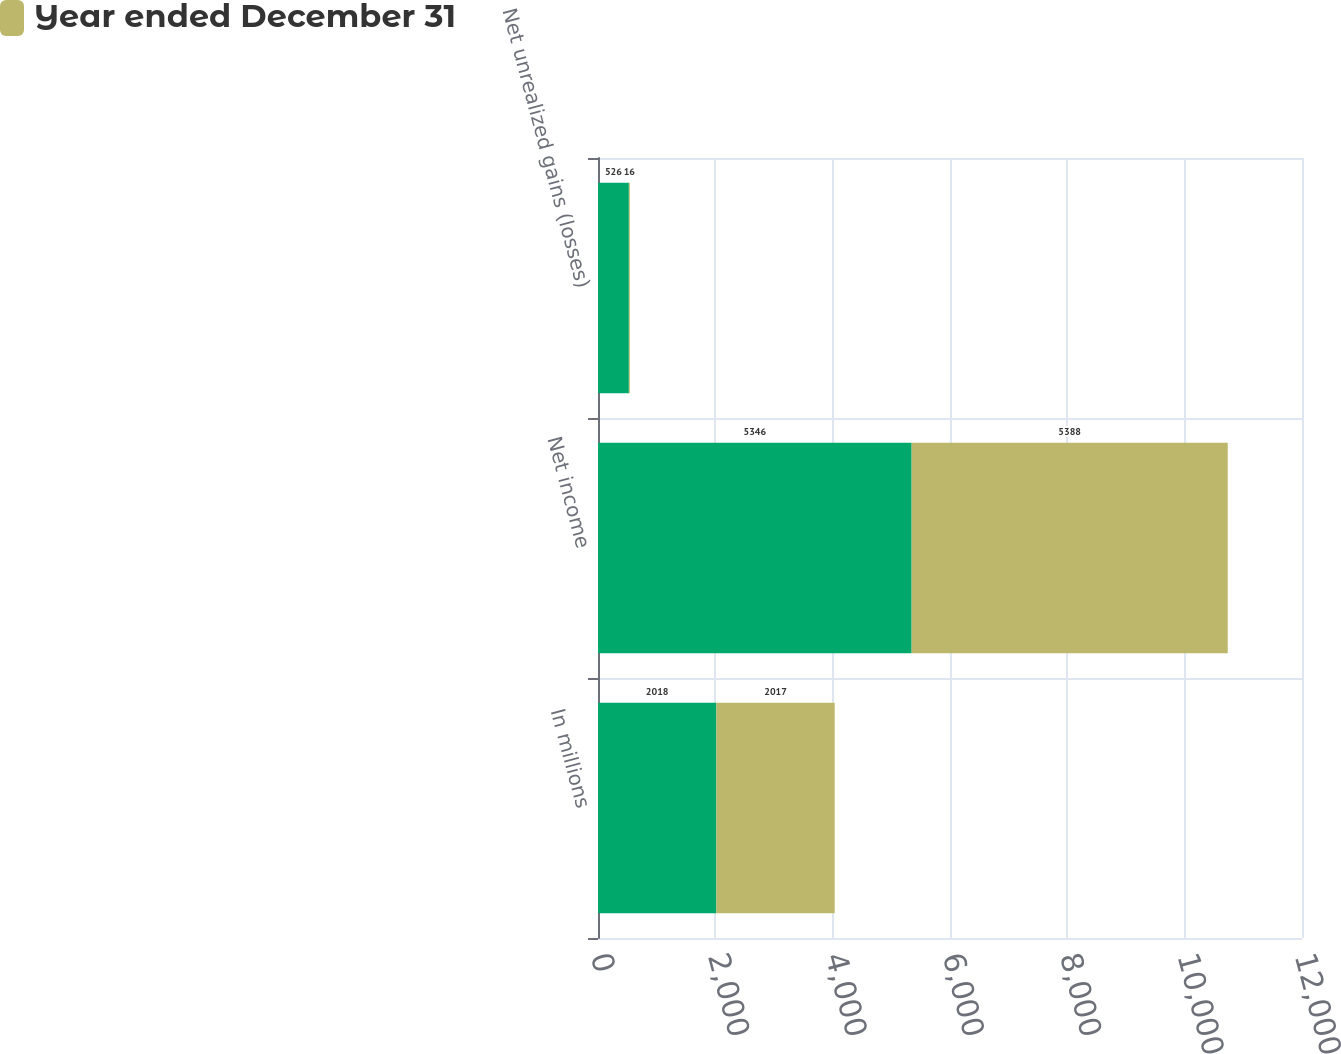<chart> <loc_0><loc_0><loc_500><loc_500><stacked_bar_chart><ecel><fcel>In millions<fcel>Net income<fcel>Net unrealized gains (losses)<nl><fcel>nan<fcel>2018<fcel>5346<fcel>526<nl><fcel>Year ended December 31<fcel>2017<fcel>5388<fcel>16<nl></chart> 